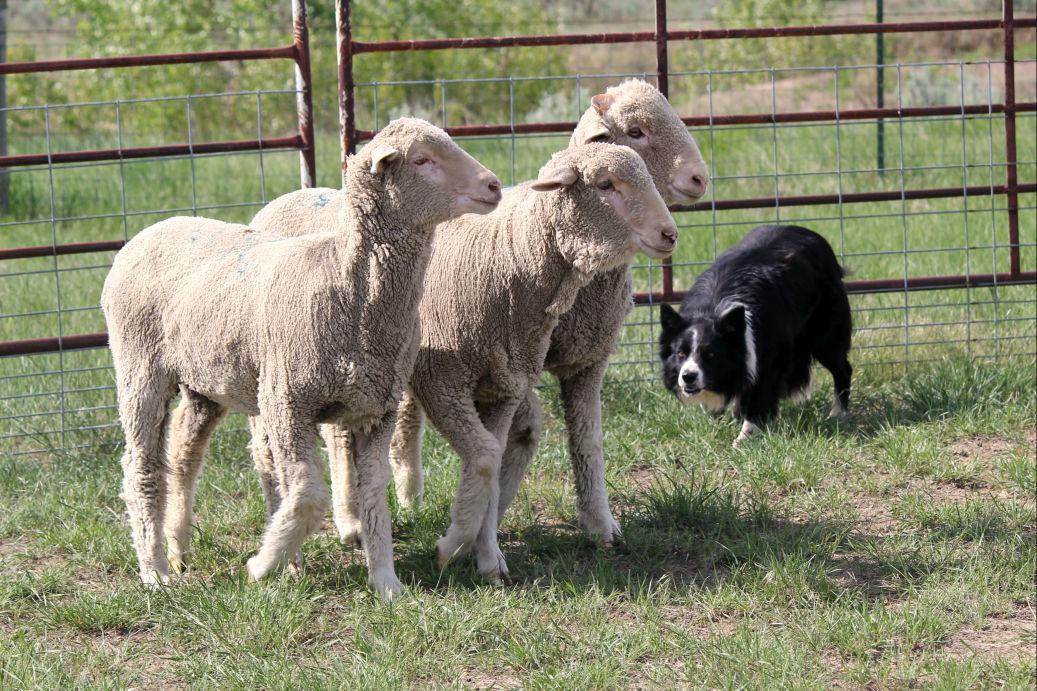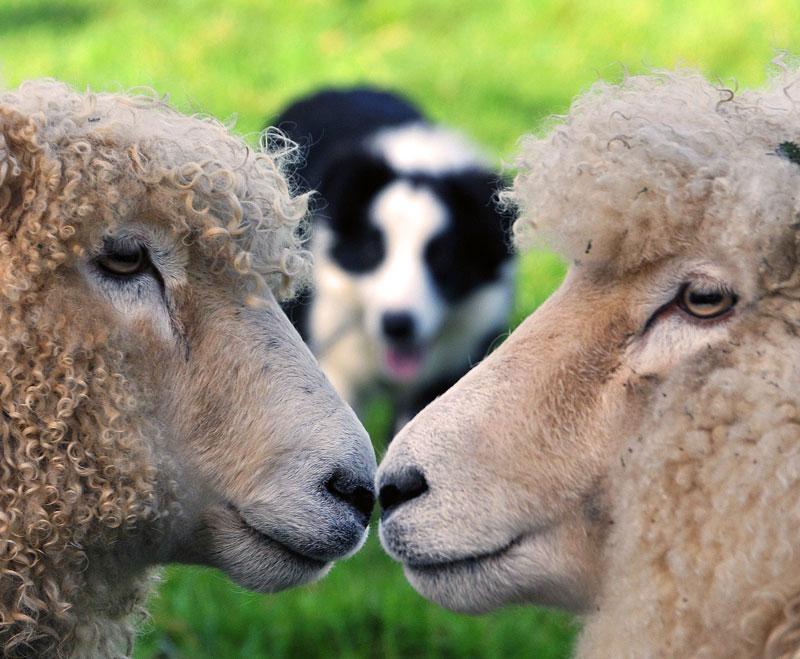The first image is the image on the left, the second image is the image on the right. Evaluate the accuracy of this statement regarding the images: "An image shows just one herd dog behind and to the left of a group of sheep.". Is it true? Answer yes or no. No. The first image is the image on the left, the second image is the image on the right. Analyze the images presented: Is the assertion "One of the images contains exactly three sheep" valid? Answer yes or no. Yes. 